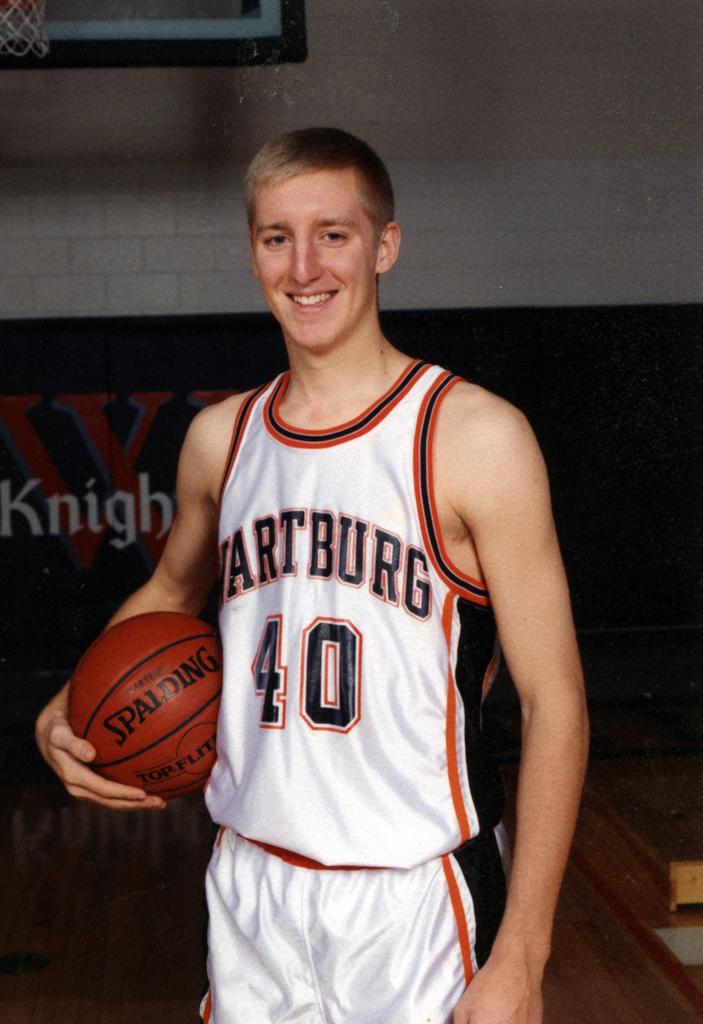What number is this player?
Keep it short and to the point. 40. What team does the boy play for?
Keep it short and to the point. Wartburg. 